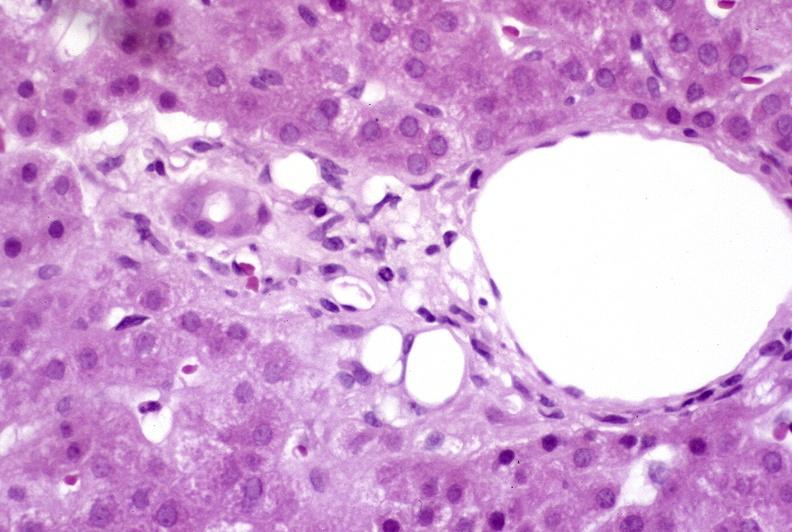s female reproductive present?
Answer the question using a single word or phrase. No 